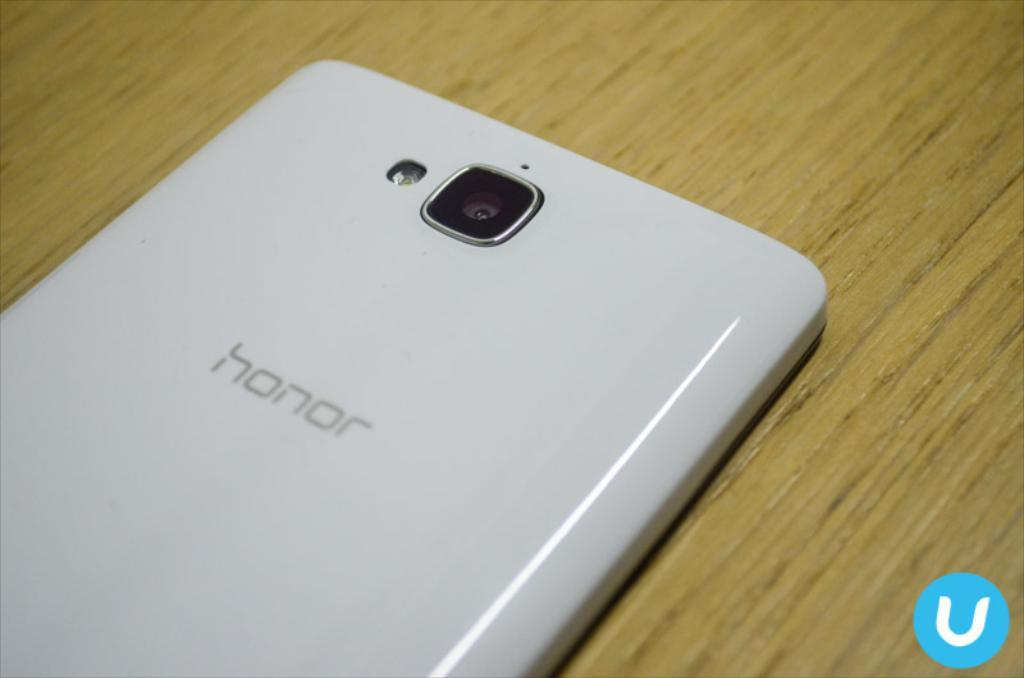What is the main object in the image? There is a mobile in the image. On what surface is the mobile placed? The mobile is on a wooden surface. Is there any additional information about the image itself? Yes, there is a watermark in the right bottom of the image. What type of music can be heard coming from the mobile in the image? The mobile in the image is not producing any music, so it cannot be heard. 